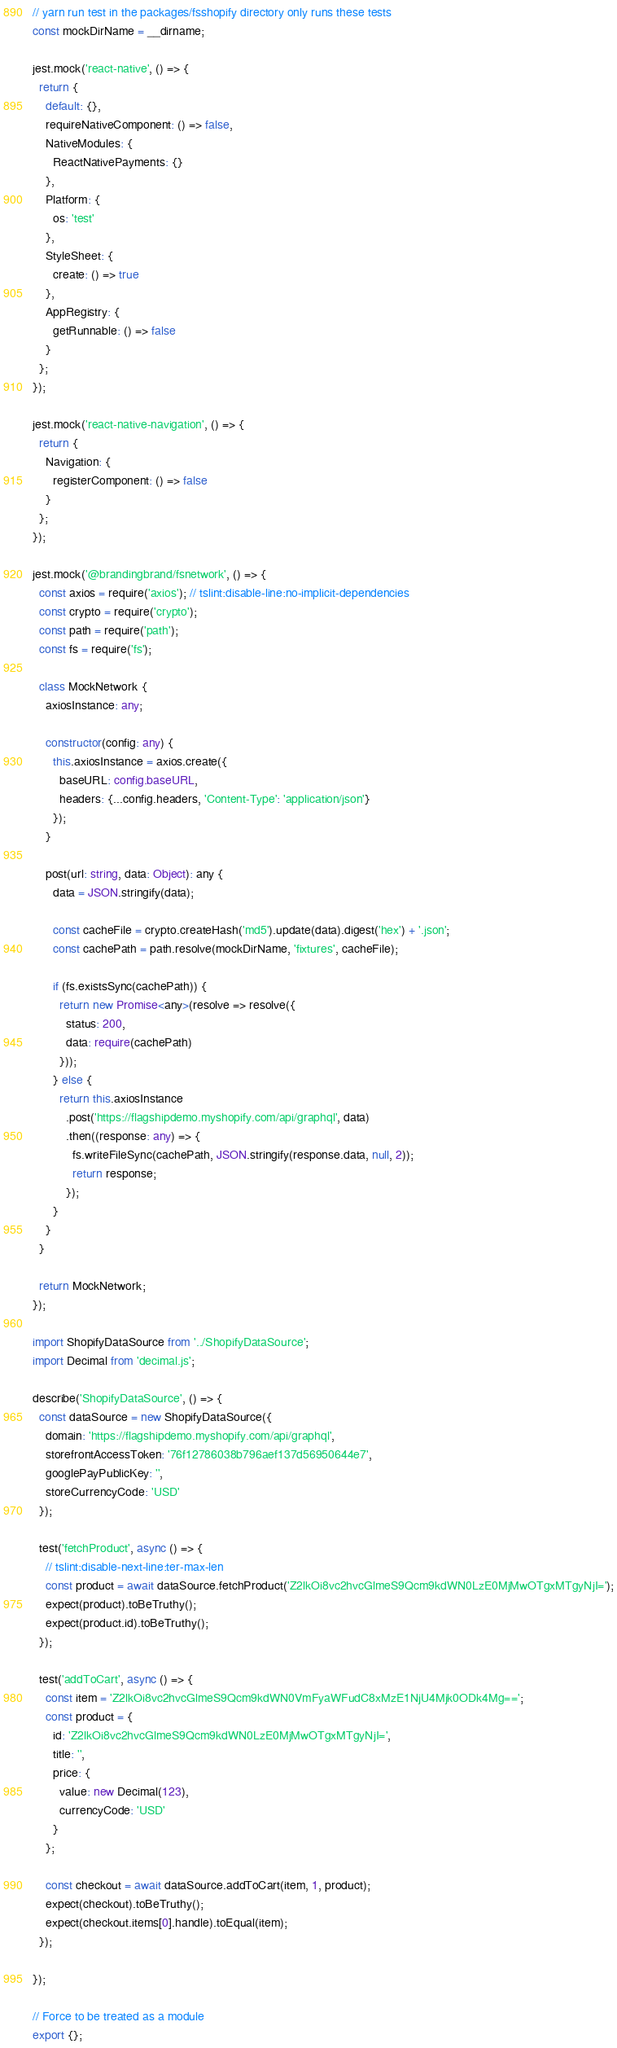Convert code to text. <code><loc_0><loc_0><loc_500><loc_500><_TypeScript_>// yarn run test in the packages/fsshopify directory only runs these tests
const mockDirName = __dirname;

jest.mock('react-native', () => {
  return {
    default: {},
    requireNativeComponent: () => false,
    NativeModules: {
      ReactNativePayments: {}
    },
    Platform: {
      os: 'test'
    },
    StyleSheet: {
      create: () => true
    },
    AppRegistry: {
      getRunnable: () => false
    }
  };
});

jest.mock('react-native-navigation', () => {
  return {
    Navigation: {
      registerComponent: () => false
    }
  };
});

jest.mock('@brandingbrand/fsnetwork', () => {
  const axios = require('axios'); // tslint:disable-line:no-implicit-dependencies
  const crypto = require('crypto');
  const path = require('path');
  const fs = require('fs');

  class MockNetwork {
    axiosInstance: any;

    constructor(config: any) {
      this.axiosInstance = axios.create({
        baseURL: config.baseURL,
        headers: {...config.headers, 'Content-Type': 'application/json'}
      });
    }

    post(url: string, data: Object): any {
      data = JSON.stringify(data);

      const cacheFile = crypto.createHash('md5').update(data).digest('hex') + '.json';
      const cachePath = path.resolve(mockDirName, 'fixtures', cacheFile);

      if (fs.existsSync(cachePath)) {
        return new Promise<any>(resolve => resolve({
          status: 200,
          data: require(cachePath)
        }));
      } else {
        return this.axiosInstance
          .post('https://flagshipdemo.myshopify.com/api/graphql', data)
          .then((response: any) => {
            fs.writeFileSync(cachePath, JSON.stringify(response.data, null, 2));
            return response;
          });
      }
    }
  }

  return MockNetwork;
});

import ShopifyDataSource from '../ShopifyDataSource';
import Decimal from 'decimal.js';

describe('ShopifyDataSource', () => {
  const dataSource = new ShopifyDataSource({
    domain: 'https://flagshipdemo.myshopify.com/api/graphql',
    storefrontAccessToken: '76f12786038b796aef137d56950644e7',
    googlePayPublicKey: '',
    storeCurrencyCode: 'USD'
  });

  test('fetchProduct', async () => {
    // tslint:disable-next-line:ter-max-len
    const product = await dataSource.fetchProduct('Z2lkOi8vc2hvcGlmeS9Qcm9kdWN0LzE0MjMwOTgxMTgyNjI=');
    expect(product).toBeTruthy();
    expect(product.id).toBeTruthy();
  });

  test('addToCart', async () => {
    const item = 'Z2lkOi8vc2hvcGlmeS9Qcm9kdWN0VmFyaWFudC8xMzE1NjU4Mjk0ODk4Mg==';
    const product = {
      id: 'Z2lkOi8vc2hvcGlmeS9Qcm9kdWN0LzE0MjMwOTgxMTgyNjI=',
      title: '',
      price: {
        value: new Decimal(123),
        currencyCode: 'USD'
      }
    };

    const checkout = await dataSource.addToCart(item, 1, product);
    expect(checkout).toBeTruthy();
    expect(checkout.items[0].handle).toEqual(item);
  });

});

// Force to be treated as a module
export {};
</code> 